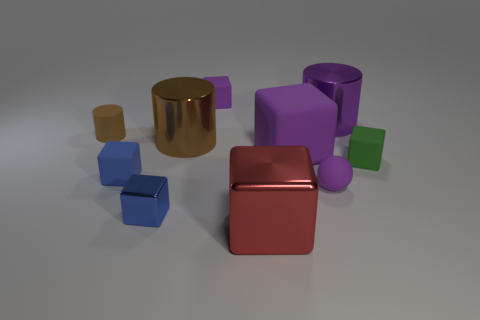Subtract all purple cubes. How many cubes are left? 4 Subtract all big rubber cubes. How many cubes are left? 5 Subtract 1 blocks. How many blocks are left? 5 Subtract all brown cubes. Subtract all gray balls. How many cubes are left? 6 Subtract all balls. How many objects are left? 9 Subtract all big cubes. Subtract all large purple rubber cubes. How many objects are left? 7 Add 2 tiny purple rubber spheres. How many tiny purple rubber spheres are left? 3 Add 8 red matte blocks. How many red matte blocks exist? 8 Subtract 0 cyan cubes. How many objects are left? 10 